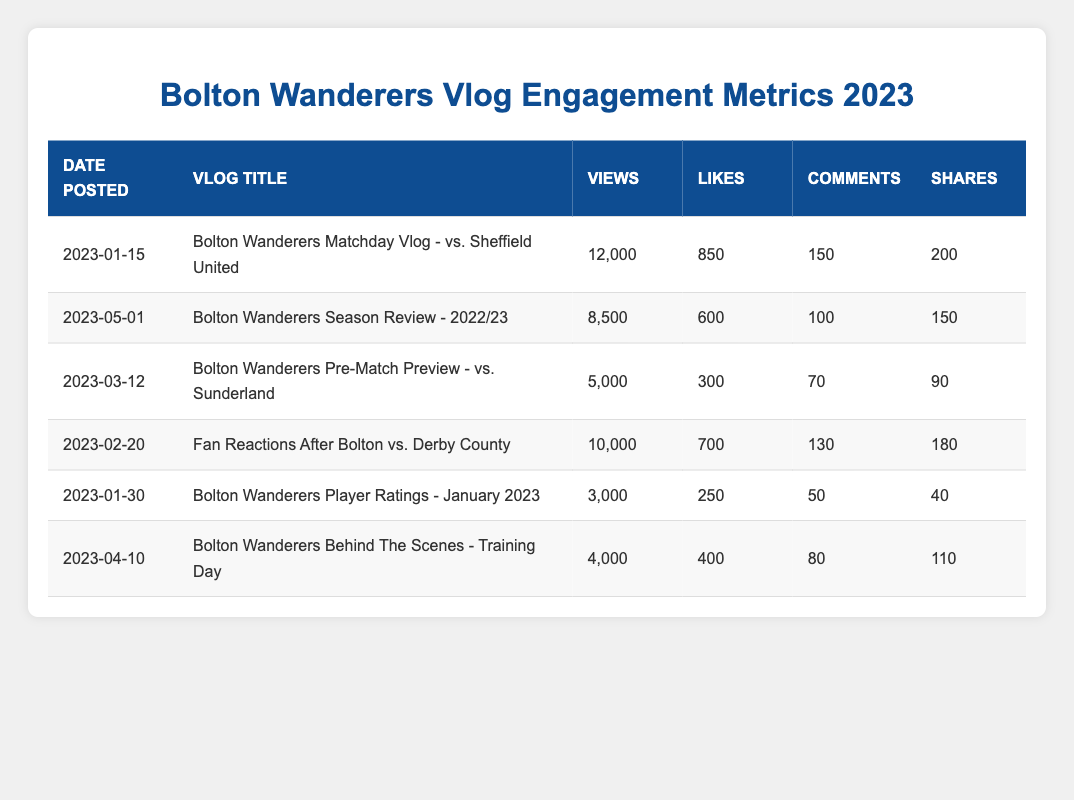What is the vlog with the highest number of views? The highest number of views can be found by examining the "Views" column. The maximum value is 12,000, which corresponds to the vlog titled "Bolton Wanderers Matchday Vlog - vs. Sheffield United" dated 2023-01-15.
Answer: 12,000 How many likes did the "Bolton Wanderers Season Review - 2022/23" vlog receive? Referring to the "Likes" column for the corresponding vlog titled "Bolton Wanderers Season Review - 2022/23," we find that it received 600 likes.
Answer: 600 Which vlog had the least number of shares? To find the vlog with the least shares, we look at the "Shares" column. The minimum value is 40, which corresponds to the vlog "Bolton Wanderers Player Ratings - January 2023" dated 2023-01-30.
Answer: 40 What is the total number of comments across all vlogs? We need to sum the "Comments" column: 150 + 100 + 70 + 130 + 50 + 80 = 680. Thus, the total number of comments across all vlogs is 680.
Answer: 680 Did any vlog posted after March 1st, 2023, have more than 5,000 views? We check the vlogs posted after March 1st, 2023. "Bolton Wanderers Season Review - 2022/23" has 8,500 views and "Bolton Wanderers Behind The Scenes - Training Day" has 4,000 views. Since 8,500 is greater than 5,000, the answer is yes.
Answer: Yes What was the average number of shares for all the vlogs? To find the average, we sum the "Shares" column: 200 + 150 + 90 + 180 + 40 + 110 = 770, then divide by the number of vlogs (6): 770 / 6 = 128.33. Thus, the average number of shares is approximately 128.33.
Answer: 128.33 Which month had the most vlogs posted? We need to analyze the "Date Posted" column. The vlogs in January (3), February (2), March (1), April (2), and May (1). January has the most vlogs posted (3).
Answer: January What is the total number of views for all vlogs posted in January 2023? We identify the vlogs posted in January: "Bolton Wanderers Matchday Vlog - vs. Sheffield United" (12,000) and "Bolton Wanderers Player Ratings - January 2023" (3,000). Adding these together gives 12,000 + 3,000 = 15,000.
Answer: 15,000 